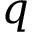<formula> <loc_0><loc_0><loc_500><loc_500>q</formula> 